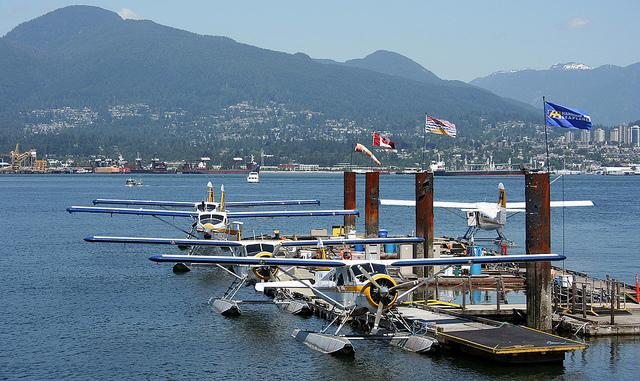What are the planes near the dock called? seaplanes 